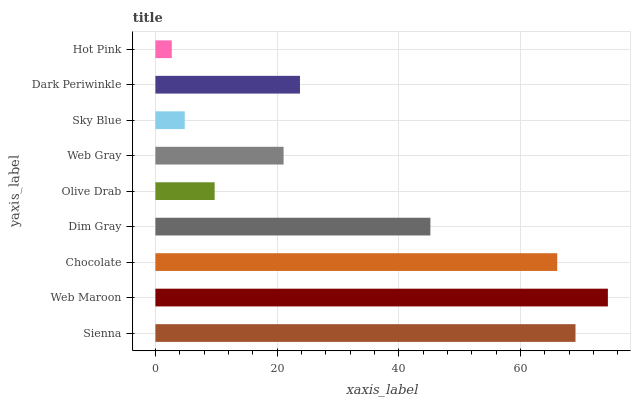Is Hot Pink the minimum?
Answer yes or no. Yes. Is Web Maroon the maximum?
Answer yes or no. Yes. Is Chocolate the minimum?
Answer yes or no. No. Is Chocolate the maximum?
Answer yes or no. No. Is Web Maroon greater than Chocolate?
Answer yes or no. Yes. Is Chocolate less than Web Maroon?
Answer yes or no. Yes. Is Chocolate greater than Web Maroon?
Answer yes or no. No. Is Web Maroon less than Chocolate?
Answer yes or no. No. Is Dark Periwinkle the high median?
Answer yes or no. Yes. Is Dark Periwinkle the low median?
Answer yes or no. Yes. Is Sky Blue the high median?
Answer yes or no. No. Is Olive Drab the low median?
Answer yes or no. No. 